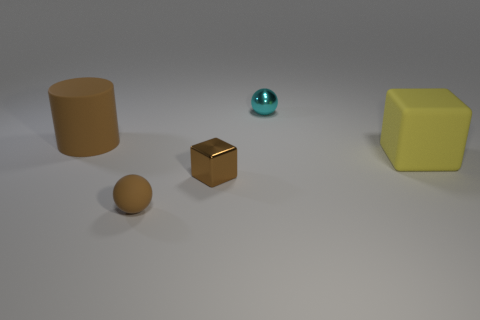There is a small object that is the same shape as the large yellow object; what material is it?
Provide a short and direct response. Metal. There is a brown matte object to the right of the brown matte cylinder; how big is it?
Your answer should be very brief. Small. Is there a tiny cyan ball made of the same material as the small cube?
Provide a short and direct response. Yes. Do the rubber thing in front of the large yellow matte object and the big matte cylinder have the same color?
Your answer should be very brief. Yes. Are there an equal number of big brown cylinders that are on the right side of the rubber ball and large brown matte cylinders?
Provide a short and direct response. No. Is there a small rubber cylinder of the same color as the large cube?
Offer a terse response. No. Does the brown shiny thing have the same size as the cyan metal ball?
Ensure brevity in your answer.  Yes. What is the size of the cube to the left of the cube behind the small brown cube?
Keep it short and to the point. Small. There is a rubber object that is to the left of the brown metal thing and in front of the big brown matte cylinder; what is its size?
Give a very brief answer. Small. How many other metallic objects have the same size as the brown metallic object?
Keep it short and to the point. 1. 